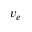<formula> <loc_0><loc_0><loc_500><loc_500>v _ { e }</formula> 